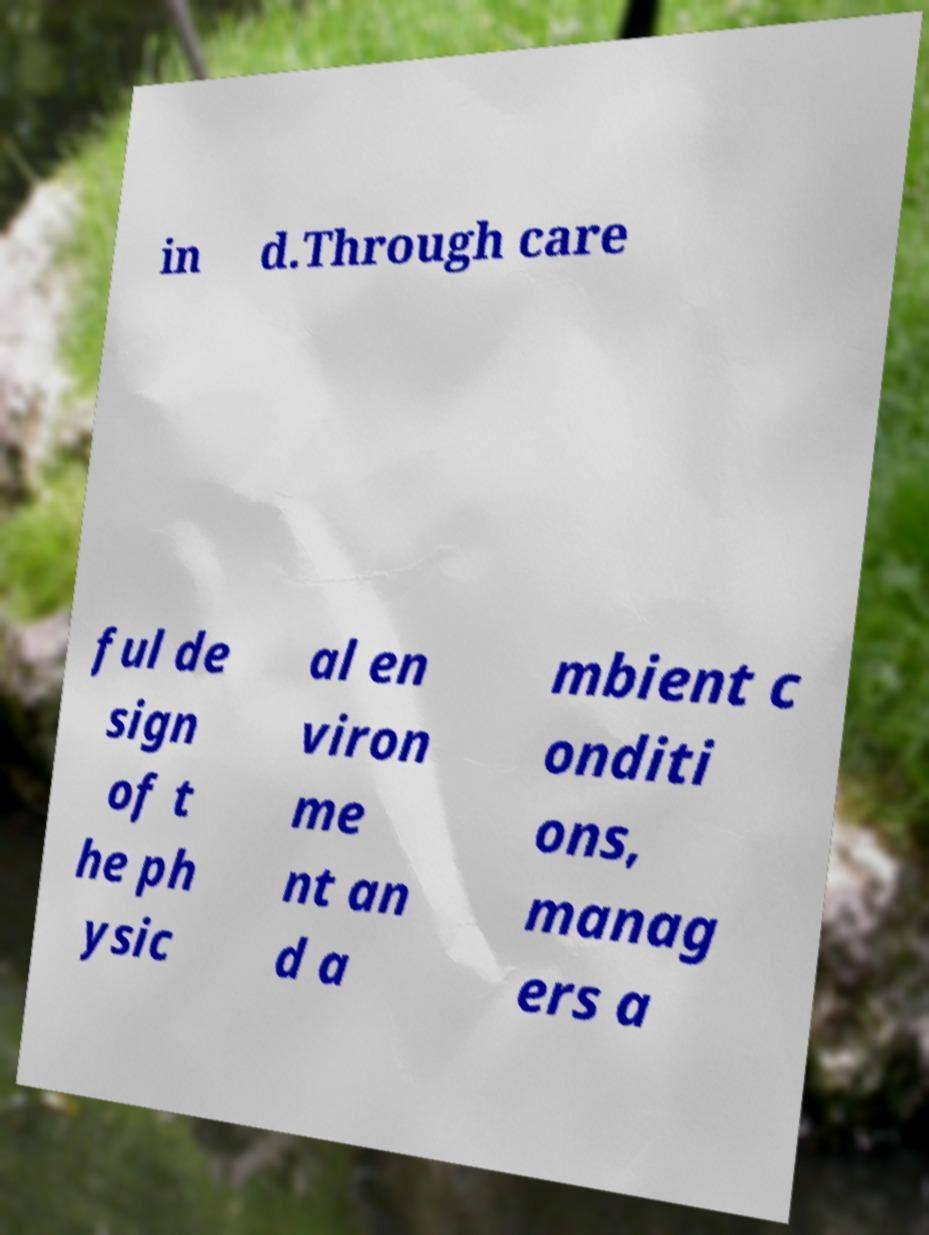Could you assist in decoding the text presented in this image and type it out clearly? in d.Through care ful de sign of t he ph ysic al en viron me nt an d a mbient c onditi ons, manag ers a 